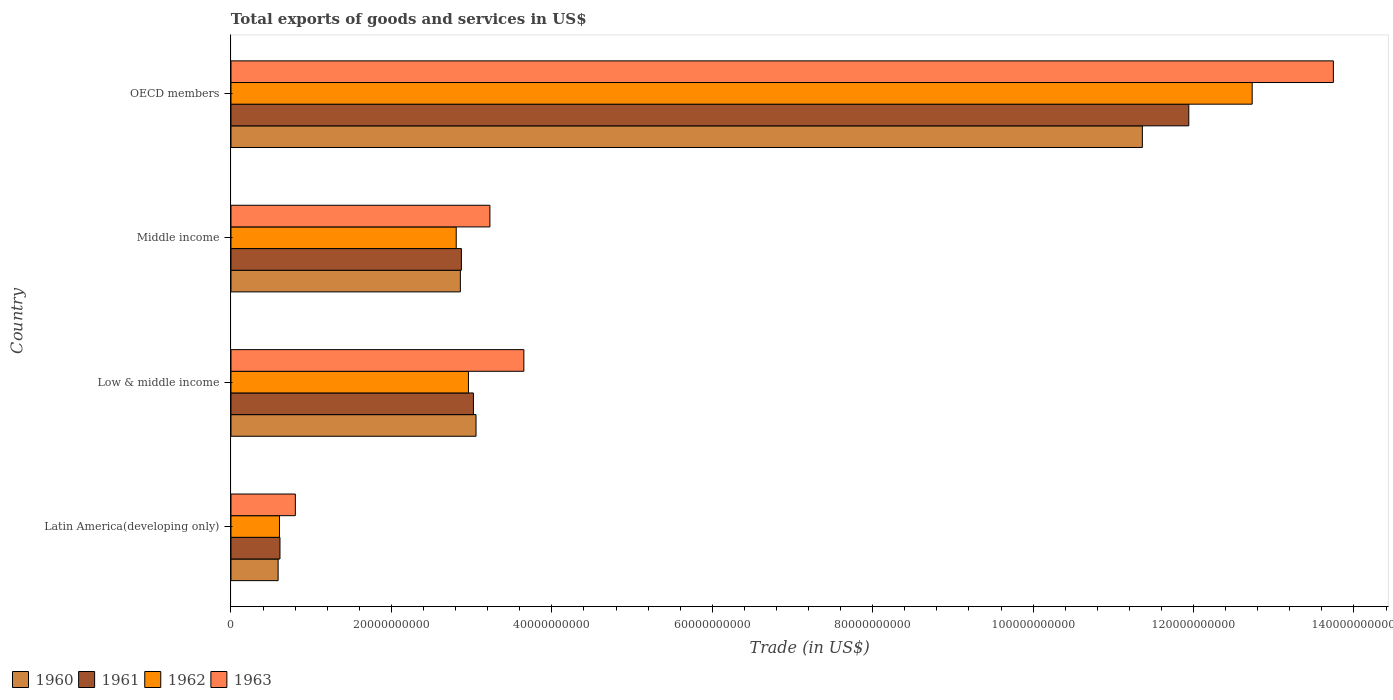How many groups of bars are there?
Provide a succinct answer. 4. Are the number of bars per tick equal to the number of legend labels?
Provide a short and direct response. Yes. How many bars are there on the 4th tick from the bottom?
Ensure brevity in your answer.  4. What is the total exports of goods and services in 1961 in Latin America(developing only)?
Offer a very short reply. 6.11e+09. Across all countries, what is the maximum total exports of goods and services in 1961?
Ensure brevity in your answer.  1.19e+11. Across all countries, what is the minimum total exports of goods and services in 1961?
Provide a short and direct response. 6.11e+09. In which country was the total exports of goods and services in 1963 minimum?
Provide a succinct answer. Latin America(developing only). What is the total total exports of goods and services in 1962 in the graph?
Provide a succinct answer. 1.91e+11. What is the difference between the total exports of goods and services in 1962 in Middle income and that in OECD members?
Your response must be concise. -9.92e+1. What is the difference between the total exports of goods and services in 1961 in OECD members and the total exports of goods and services in 1963 in Latin America(developing only)?
Offer a very short reply. 1.11e+11. What is the average total exports of goods and services in 1962 per country?
Make the answer very short. 4.78e+1. What is the difference between the total exports of goods and services in 1963 and total exports of goods and services in 1962 in Latin America(developing only)?
Your answer should be very brief. 1.98e+09. In how many countries, is the total exports of goods and services in 1963 greater than 80000000000 US$?
Ensure brevity in your answer.  1. What is the ratio of the total exports of goods and services in 1961 in Low & middle income to that in OECD members?
Your response must be concise. 0.25. What is the difference between the highest and the second highest total exports of goods and services in 1963?
Give a very brief answer. 1.01e+11. What is the difference between the highest and the lowest total exports of goods and services in 1961?
Offer a very short reply. 1.13e+11. In how many countries, is the total exports of goods and services in 1961 greater than the average total exports of goods and services in 1961 taken over all countries?
Offer a very short reply. 1. Is the sum of the total exports of goods and services in 1963 in Middle income and OECD members greater than the maximum total exports of goods and services in 1961 across all countries?
Provide a succinct answer. Yes. Is it the case that in every country, the sum of the total exports of goods and services in 1960 and total exports of goods and services in 1961 is greater than the sum of total exports of goods and services in 1962 and total exports of goods and services in 1963?
Offer a terse response. No. What does the 1st bar from the top in OECD members represents?
Make the answer very short. 1963. What does the 4th bar from the bottom in Latin America(developing only) represents?
Give a very brief answer. 1963. Is it the case that in every country, the sum of the total exports of goods and services in 1961 and total exports of goods and services in 1960 is greater than the total exports of goods and services in 1962?
Your response must be concise. Yes. How many bars are there?
Your response must be concise. 16. Are the values on the major ticks of X-axis written in scientific E-notation?
Make the answer very short. No. Where does the legend appear in the graph?
Your answer should be very brief. Bottom left. How many legend labels are there?
Ensure brevity in your answer.  4. How are the legend labels stacked?
Provide a succinct answer. Horizontal. What is the title of the graph?
Offer a very short reply. Total exports of goods and services in US$. What is the label or title of the X-axis?
Your answer should be compact. Trade (in US$). What is the label or title of the Y-axis?
Provide a short and direct response. Country. What is the Trade (in US$) in 1960 in Latin America(developing only)?
Offer a very short reply. 5.88e+09. What is the Trade (in US$) in 1961 in Latin America(developing only)?
Offer a very short reply. 6.11e+09. What is the Trade (in US$) of 1962 in Latin America(developing only)?
Ensure brevity in your answer.  6.04e+09. What is the Trade (in US$) of 1963 in Latin America(developing only)?
Provide a succinct answer. 8.02e+09. What is the Trade (in US$) in 1960 in Low & middle income?
Your answer should be compact. 3.06e+1. What is the Trade (in US$) of 1961 in Low & middle income?
Offer a very short reply. 3.02e+1. What is the Trade (in US$) of 1962 in Low & middle income?
Provide a short and direct response. 2.96e+1. What is the Trade (in US$) of 1963 in Low & middle income?
Ensure brevity in your answer.  3.65e+1. What is the Trade (in US$) in 1960 in Middle income?
Your answer should be compact. 2.86e+1. What is the Trade (in US$) of 1961 in Middle income?
Offer a very short reply. 2.87e+1. What is the Trade (in US$) of 1962 in Middle income?
Make the answer very short. 2.81e+1. What is the Trade (in US$) of 1963 in Middle income?
Offer a terse response. 3.23e+1. What is the Trade (in US$) in 1960 in OECD members?
Provide a short and direct response. 1.14e+11. What is the Trade (in US$) of 1961 in OECD members?
Make the answer very short. 1.19e+11. What is the Trade (in US$) of 1962 in OECD members?
Provide a short and direct response. 1.27e+11. What is the Trade (in US$) in 1963 in OECD members?
Your answer should be compact. 1.37e+11. Across all countries, what is the maximum Trade (in US$) of 1960?
Keep it short and to the point. 1.14e+11. Across all countries, what is the maximum Trade (in US$) of 1961?
Provide a short and direct response. 1.19e+11. Across all countries, what is the maximum Trade (in US$) of 1962?
Offer a very short reply. 1.27e+11. Across all countries, what is the maximum Trade (in US$) of 1963?
Your answer should be very brief. 1.37e+11. Across all countries, what is the minimum Trade (in US$) of 1960?
Provide a succinct answer. 5.88e+09. Across all countries, what is the minimum Trade (in US$) in 1961?
Offer a terse response. 6.11e+09. Across all countries, what is the minimum Trade (in US$) of 1962?
Your answer should be compact. 6.04e+09. Across all countries, what is the minimum Trade (in US$) in 1963?
Offer a very short reply. 8.02e+09. What is the total Trade (in US$) in 1960 in the graph?
Provide a short and direct response. 1.79e+11. What is the total Trade (in US$) in 1961 in the graph?
Offer a terse response. 1.84e+11. What is the total Trade (in US$) in 1962 in the graph?
Offer a terse response. 1.91e+11. What is the total Trade (in US$) of 1963 in the graph?
Your answer should be very brief. 2.14e+11. What is the difference between the Trade (in US$) of 1960 in Latin America(developing only) and that in Low & middle income?
Make the answer very short. -2.47e+1. What is the difference between the Trade (in US$) of 1961 in Latin America(developing only) and that in Low & middle income?
Keep it short and to the point. -2.41e+1. What is the difference between the Trade (in US$) in 1962 in Latin America(developing only) and that in Low & middle income?
Your answer should be compact. -2.36e+1. What is the difference between the Trade (in US$) of 1963 in Latin America(developing only) and that in Low & middle income?
Ensure brevity in your answer.  -2.85e+1. What is the difference between the Trade (in US$) of 1960 in Latin America(developing only) and that in Middle income?
Ensure brevity in your answer.  -2.27e+1. What is the difference between the Trade (in US$) of 1961 in Latin America(developing only) and that in Middle income?
Your answer should be compact. -2.26e+1. What is the difference between the Trade (in US$) of 1962 in Latin America(developing only) and that in Middle income?
Keep it short and to the point. -2.20e+1. What is the difference between the Trade (in US$) in 1963 in Latin America(developing only) and that in Middle income?
Make the answer very short. -2.43e+1. What is the difference between the Trade (in US$) of 1960 in Latin America(developing only) and that in OECD members?
Provide a short and direct response. -1.08e+11. What is the difference between the Trade (in US$) of 1961 in Latin America(developing only) and that in OECD members?
Offer a very short reply. -1.13e+11. What is the difference between the Trade (in US$) of 1962 in Latin America(developing only) and that in OECD members?
Provide a succinct answer. -1.21e+11. What is the difference between the Trade (in US$) in 1963 in Latin America(developing only) and that in OECD members?
Offer a terse response. -1.29e+11. What is the difference between the Trade (in US$) in 1960 in Low & middle income and that in Middle income?
Offer a very short reply. 1.96e+09. What is the difference between the Trade (in US$) in 1961 in Low & middle income and that in Middle income?
Your answer should be very brief. 1.50e+09. What is the difference between the Trade (in US$) in 1962 in Low & middle income and that in Middle income?
Give a very brief answer. 1.52e+09. What is the difference between the Trade (in US$) of 1963 in Low & middle income and that in Middle income?
Your response must be concise. 4.23e+09. What is the difference between the Trade (in US$) in 1960 in Low & middle income and that in OECD members?
Make the answer very short. -8.31e+1. What is the difference between the Trade (in US$) in 1961 in Low & middle income and that in OECD members?
Make the answer very short. -8.92e+1. What is the difference between the Trade (in US$) in 1962 in Low & middle income and that in OECD members?
Give a very brief answer. -9.77e+1. What is the difference between the Trade (in US$) of 1963 in Low & middle income and that in OECD members?
Offer a very short reply. -1.01e+11. What is the difference between the Trade (in US$) in 1960 in Middle income and that in OECD members?
Give a very brief answer. -8.50e+1. What is the difference between the Trade (in US$) in 1961 in Middle income and that in OECD members?
Offer a very short reply. -9.07e+1. What is the difference between the Trade (in US$) in 1962 in Middle income and that in OECD members?
Make the answer very short. -9.92e+1. What is the difference between the Trade (in US$) in 1963 in Middle income and that in OECD members?
Provide a succinct answer. -1.05e+11. What is the difference between the Trade (in US$) in 1960 in Latin America(developing only) and the Trade (in US$) in 1961 in Low & middle income?
Provide a succinct answer. -2.43e+1. What is the difference between the Trade (in US$) of 1960 in Latin America(developing only) and the Trade (in US$) of 1962 in Low & middle income?
Your response must be concise. -2.37e+1. What is the difference between the Trade (in US$) in 1960 in Latin America(developing only) and the Trade (in US$) in 1963 in Low & middle income?
Provide a short and direct response. -3.06e+1. What is the difference between the Trade (in US$) in 1961 in Latin America(developing only) and the Trade (in US$) in 1962 in Low & middle income?
Offer a very short reply. -2.35e+1. What is the difference between the Trade (in US$) of 1961 in Latin America(developing only) and the Trade (in US$) of 1963 in Low & middle income?
Your answer should be compact. -3.04e+1. What is the difference between the Trade (in US$) in 1962 in Latin America(developing only) and the Trade (in US$) in 1963 in Low & middle income?
Provide a short and direct response. -3.05e+1. What is the difference between the Trade (in US$) in 1960 in Latin America(developing only) and the Trade (in US$) in 1961 in Middle income?
Offer a very short reply. -2.28e+1. What is the difference between the Trade (in US$) in 1960 in Latin America(developing only) and the Trade (in US$) in 1962 in Middle income?
Give a very brief answer. -2.22e+1. What is the difference between the Trade (in US$) in 1960 in Latin America(developing only) and the Trade (in US$) in 1963 in Middle income?
Give a very brief answer. -2.64e+1. What is the difference between the Trade (in US$) in 1961 in Latin America(developing only) and the Trade (in US$) in 1962 in Middle income?
Your response must be concise. -2.20e+1. What is the difference between the Trade (in US$) in 1961 in Latin America(developing only) and the Trade (in US$) in 1963 in Middle income?
Provide a short and direct response. -2.62e+1. What is the difference between the Trade (in US$) of 1962 in Latin America(developing only) and the Trade (in US$) of 1963 in Middle income?
Provide a short and direct response. -2.62e+1. What is the difference between the Trade (in US$) in 1960 in Latin America(developing only) and the Trade (in US$) in 1961 in OECD members?
Your answer should be compact. -1.14e+11. What is the difference between the Trade (in US$) in 1960 in Latin America(developing only) and the Trade (in US$) in 1962 in OECD members?
Your response must be concise. -1.21e+11. What is the difference between the Trade (in US$) in 1960 in Latin America(developing only) and the Trade (in US$) in 1963 in OECD members?
Your answer should be very brief. -1.32e+11. What is the difference between the Trade (in US$) of 1961 in Latin America(developing only) and the Trade (in US$) of 1962 in OECD members?
Your response must be concise. -1.21e+11. What is the difference between the Trade (in US$) of 1961 in Latin America(developing only) and the Trade (in US$) of 1963 in OECD members?
Ensure brevity in your answer.  -1.31e+11. What is the difference between the Trade (in US$) in 1962 in Latin America(developing only) and the Trade (in US$) in 1963 in OECD members?
Offer a very short reply. -1.31e+11. What is the difference between the Trade (in US$) of 1960 in Low & middle income and the Trade (in US$) of 1961 in Middle income?
Provide a short and direct response. 1.83e+09. What is the difference between the Trade (in US$) of 1960 in Low & middle income and the Trade (in US$) of 1962 in Middle income?
Offer a terse response. 2.47e+09. What is the difference between the Trade (in US$) in 1960 in Low & middle income and the Trade (in US$) in 1963 in Middle income?
Offer a terse response. -1.73e+09. What is the difference between the Trade (in US$) of 1961 in Low & middle income and the Trade (in US$) of 1962 in Middle income?
Give a very brief answer. 2.15e+09. What is the difference between the Trade (in US$) in 1961 in Low & middle income and the Trade (in US$) in 1963 in Middle income?
Provide a succinct answer. -2.05e+09. What is the difference between the Trade (in US$) of 1962 in Low & middle income and the Trade (in US$) of 1963 in Middle income?
Keep it short and to the point. -2.68e+09. What is the difference between the Trade (in US$) of 1960 in Low & middle income and the Trade (in US$) of 1961 in OECD members?
Provide a succinct answer. -8.89e+1. What is the difference between the Trade (in US$) in 1960 in Low & middle income and the Trade (in US$) in 1962 in OECD members?
Give a very brief answer. -9.68e+1. What is the difference between the Trade (in US$) of 1960 in Low & middle income and the Trade (in US$) of 1963 in OECD members?
Ensure brevity in your answer.  -1.07e+11. What is the difference between the Trade (in US$) of 1961 in Low & middle income and the Trade (in US$) of 1962 in OECD members?
Offer a terse response. -9.71e+1. What is the difference between the Trade (in US$) in 1961 in Low & middle income and the Trade (in US$) in 1963 in OECD members?
Offer a terse response. -1.07e+11. What is the difference between the Trade (in US$) in 1962 in Low & middle income and the Trade (in US$) in 1963 in OECD members?
Offer a terse response. -1.08e+11. What is the difference between the Trade (in US$) of 1960 in Middle income and the Trade (in US$) of 1961 in OECD members?
Provide a short and direct response. -9.08e+1. What is the difference between the Trade (in US$) of 1960 in Middle income and the Trade (in US$) of 1962 in OECD members?
Your answer should be compact. -9.87e+1. What is the difference between the Trade (in US$) in 1960 in Middle income and the Trade (in US$) in 1963 in OECD members?
Give a very brief answer. -1.09e+11. What is the difference between the Trade (in US$) of 1961 in Middle income and the Trade (in US$) of 1962 in OECD members?
Offer a terse response. -9.86e+1. What is the difference between the Trade (in US$) of 1961 in Middle income and the Trade (in US$) of 1963 in OECD members?
Offer a very short reply. -1.09e+11. What is the difference between the Trade (in US$) of 1962 in Middle income and the Trade (in US$) of 1963 in OECD members?
Your answer should be very brief. -1.09e+11. What is the average Trade (in US$) of 1960 per country?
Keep it short and to the point. 4.47e+1. What is the average Trade (in US$) of 1961 per country?
Make the answer very short. 4.61e+1. What is the average Trade (in US$) of 1962 per country?
Ensure brevity in your answer.  4.78e+1. What is the average Trade (in US$) in 1963 per country?
Your response must be concise. 5.36e+1. What is the difference between the Trade (in US$) in 1960 and Trade (in US$) in 1961 in Latin America(developing only)?
Provide a succinct answer. -2.30e+08. What is the difference between the Trade (in US$) of 1960 and Trade (in US$) of 1962 in Latin America(developing only)?
Provide a short and direct response. -1.67e+08. What is the difference between the Trade (in US$) of 1960 and Trade (in US$) of 1963 in Latin America(developing only)?
Your response must be concise. -2.15e+09. What is the difference between the Trade (in US$) in 1961 and Trade (in US$) in 1962 in Latin America(developing only)?
Give a very brief answer. 6.28e+07. What is the difference between the Trade (in US$) of 1961 and Trade (in US$) of 1963 in Latin America(developing only)?
Make the answer very short. -1.92e+09. What is the difference between the Trade (in US$) in 1962 and Trade (in US$) in 1963 in Latin America(developing only)?
Your answer should be compact. -1.98e+09. What is the difference between the Trade (in US$) of 1960 and Trade (in US$) of 1961 in Low & middle income?
Ensure brevity in your answer.  3.25e+08. What is the difference between the Trade (in US$) of 1960 and Trade (in US$) of 1962 in Low & middle income?
Your answer should be very brief. 9.47e+08. What is the difference between the Trade (in US$) in 1960 and Trade (in US$) in 1963 in Low & middle income?
Ensure brevity in your answer.  -5.96e+09. What is the difference between the Trade (in US$) in 1961 and Trade (in US$) in 1962 in Low & middle income?
Your answer should be compact. 6.22e+08. What is the difference between the Trade (in US$) in 1961 and Trade (in US$) in 1963 in Low & middle income?
Your answer should be very brief. -6.29e+09. What is the difference between the Trade (in US$) in 1962 and Trade (in US$) in 1963 in Low & middle income?
Your answer should be compact. -6.91e+09. What is the difference between the Trade (in US$) of 1960 and Trade (in US$) of 1961 in Middle income?
Keep it short and to the point. -1.30e+08. What is the difference between the Trade (in US$) in 1960 and Trade (in US$) in 1962 in Middle income?
Give a very brief answer. 5.16e+08. What is the difference between the Trade (in US$) of 1960 and Trade (in US$) of 1963 in Middle income?
Your answer should be very brief. -3.68e+09. What is the difference between the Trade (in US$) of 1961 and Trade (in US$) of 1962 in Middle income?
Your response must be concise. 6.46e+08. What is the difference between the Trade (in US$) in 1961 and Trade (in US$) in 1963 in Middle income?
Make the answer very short. -3.56e+09. What is the difference between the Trade (in US$) of 1962 and Trade (in US$) of 1963 in Middle income?
Provide a short and direct response. -4.20e+09. What is the difference between the Trade (in US$) of 1960 and Trade (in US$) of 1961 in OECD members?
Your response must be concise. -5.79e+09. What is the difference between the Trade (in US$) of 1960 and Trade (in US$) of 1962 in OECD members?
Ensure brevity in your answer.  -1.37e+1. What is the difference between the Trade (in US$) of 1960 and Trade (in US$) of 1963 in OECD members?
Keep it short and to the point. -2.38e+1. What is the difference between the Trade (in US$) of 1961 and Trade (in US$) of 1962 in OECD members?
Provide a short and direct response. -7.90e+09. What is the difference between the Trade (in US$) in 1961 and Trade (in US$) in 1963 in OECD members?
Offer a terse response. -1.80e+1. What is the difference between the Trade (in US$) of 1962 and Trade (in US$) of 1963 in OECD members?
Keep it short and to the point. -1.01e+1. What is the ratio of the Trade (in US$) of 1960 in Latin America(developing only) to that in Low & middle income?
Your answer should be very brief. 0.19. What is the ratio of the Trade (in US$) in 1961 in Latin America(developing only) to that in Low & middle income?
Your response must be concise. 0.2. What is the ratio of the Trade (in US$) of 1962 in Latin America(developing only) to that in Low & middle income?
Give a very brief answer. 0.2. What is the ratio of the Trade (in US$) of 1963 in Latin America(developing only) to that in Low & middle income?
Keep it short and to the point. 0.22. What is the ratio of the Trade (in US$) of 1960 in Latin America(developing only) to that in Middle income?
Keep it short and to the point. 0.21. What is the ratio of the Trade (in US$) in 1961 in Latin America(developing only) to that in Middle income?
Keep it short and to the point. 0.21. What is the ratio of the Trade (in US$) of 1962 in Latin America(developing only) to that in Middle income?
Provide a succinct answer. 0.22. What is the ratio of the Trade (in US$) in 1963 in Latin America(developing only) to that in Middle income?
Give a very brief answer. 0.25. What is the ratio of the Trade (in US$) of 1960 in Latin America(developing only) to that in OECD members?
Your answer should be compact. 0.05. What is the ratio of the Trade (in US$) in 1961 in Latin America(developing only) to that in OECD members?
Offer a terse response. 0.05. What is the ratio of the Trade (in US$) of 1962 in Latin America(developing only) to that in OECD members?
Your answer should be very brief. 0.05. What is the ratio of the Trade (in US$) of 1963 in Latin America(developing only) to that in OECD members?
Offer a terse response. 0.06. What is the ratio of the Trade (in US$) in 1960 in Low & middle income to that in Middle income?
Provide a short and direct response. 1.07. What is the ratio of the Trade (in US$) in 1961 in Low & middle income to that in Middle income?
Ensure brevity in your answer.  1.05. What is the ratio of the Trade (in US$) of 1962 in Low & middle income to that in Middle income?
Offer a very short reply. 1.05. What is the ratio of the Trade (in US$) in 1963 in Low & middle income to that in Middle income?
Provide a succinct answer. 1.13. What is the ratio of the Trade (in US$) in 1960 in Low & middle income to that in OECD members?
Offer a terse response. 0.27. What is the ratio of the Trade (in US$) of 1961 in Low & middle income to that in OECD members?
Your answer should be very brief. 0.25. What is the ratio of the Trade (in US$) of 1962 in Low & middle income to that in OECD members?
Your response must be concise. 0.23. What is the ratio of the Trade (in US$) of 1963 in Low & middle income to that in OECD members?
Give a very brief answer. 0.27. What is the ratio of the Trade (in US$) of 1960 in Middle income to that in OECD members?
Provide a short and direct response. 0.25. What is the ratio of the Trade (in US$) in 1961 in Middle income to that in OECD members?
Make the answer very short. 0.24. What is the ratio of the Trade (in US$) in 1962 in Middle income to that in OECD members?
Make the answer very short. 0.22. What is the ratio of the Trade (in US$) of 1963 in Middle income to that in OECD members?
Ensure brevity in your answer.  0.23. What is the difference between the highest and the second highest Trade (in US$) of 1960?
Your response must be concise. 8.31e+1. What is the difference between the highest and the second highest Trade (in US$) in 1961?
Provide a succinct answer. 8.92e+1. What is the difference between the highest and the second highest Trade (in US$) in 1962?
Your response must be concise. 9.77e+1. What is the difference between the highest and the second highest Trade (in US$) in 1963?
Your response must be concise. 1.01e+11. What is the difference between the highest and the lowest Trade (in US$) of 1960?
Offer a terse response. 1.08e+11. What is the difference between the highest and the lowest Trade (in US$) of 1961?
Make the answer very short. 1.13e+11. What is the difference between the highest and the lowest Trade (in US$) in 1962?
Give a very brief answer. 1.21e+11. What is the difference between the highest and the lowest Trade (in US$) in 1963?
Your answer should be compact. 1.29e+11. 